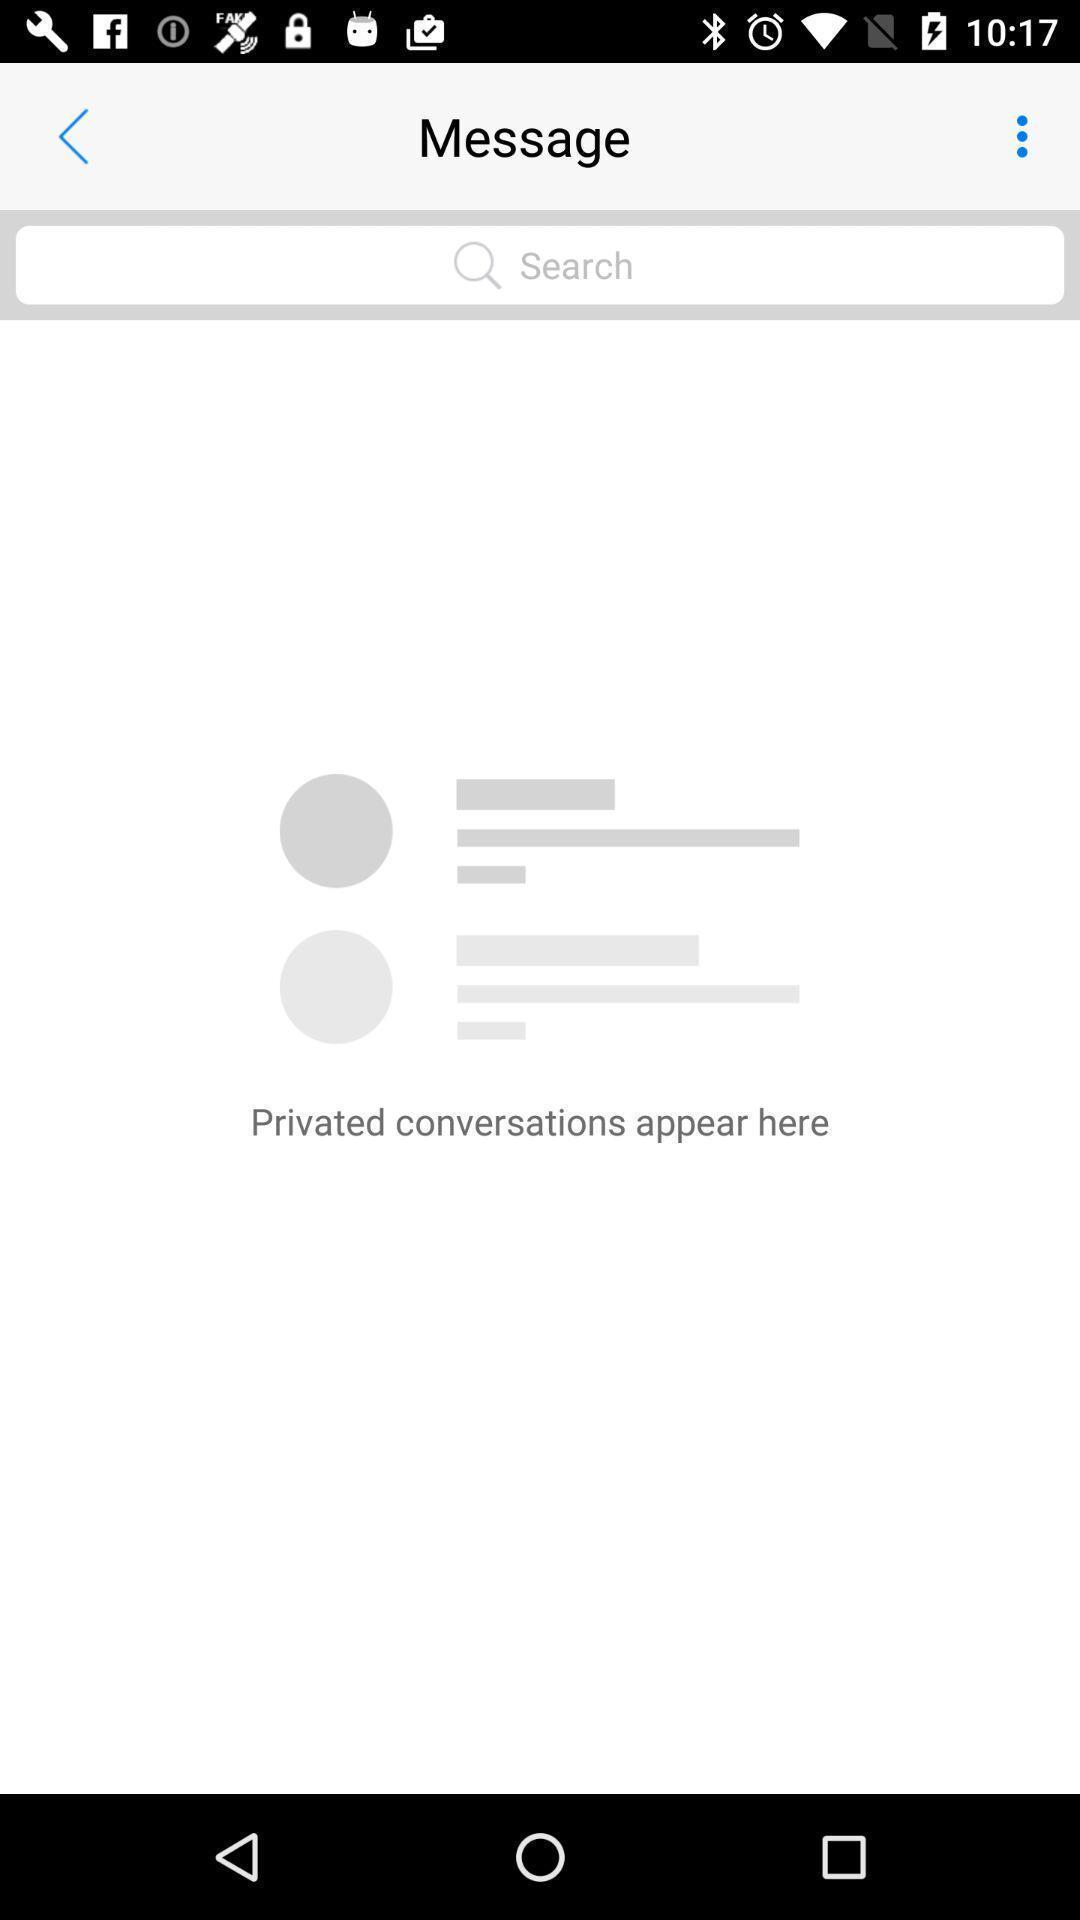Describe the content in this image. Page showing search bar to find conversations in social app. 